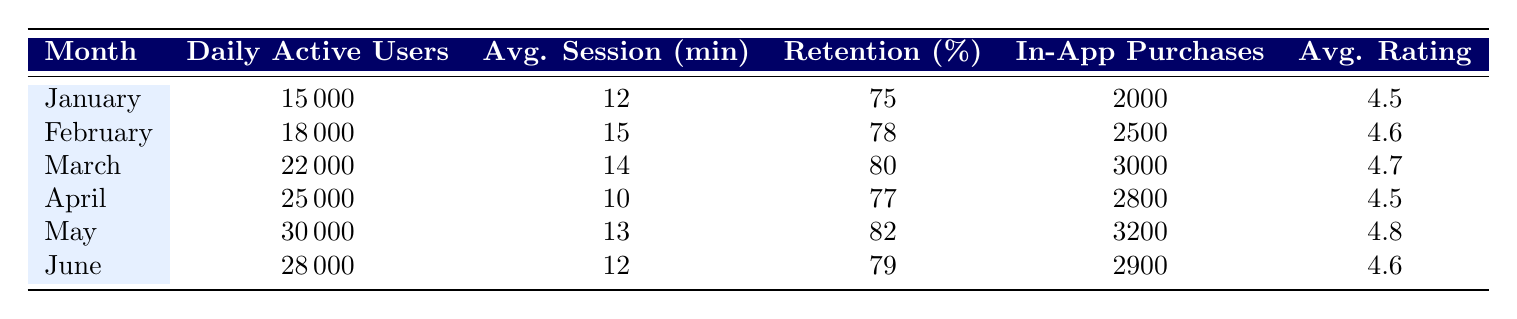What were the daily active users in March? In March, the row corresponding to that month shows 22000 daily active users.
Answer: 22000 What was the average session length in May? The average session length for May is directly provided in the table as 13 minutes.
Answer: 13 Did the user retention rate increase from February to March? In February, the user retention rate was 78%, while in March it was 80%. Since 80% is greater than 78%, the retention rate did increase from February to March.
Answer: Yes Which month had the highest number of in-app purchases? To find the highest in-app purchases, we compare the values: January (2000), February (2500), March (3000), April (2800), May (3200), and June (2900). The highest value is 3200 in May.
Answer: May What is the average rating across all six months? To calculate the average rating, sum the ratings (4.5 + 4.6 + 4.7 + 4.5 + 4.8 + 4.6 = 27.7) and divide by the number of months (6). Thus, 27.7 / 6 = 4.61667, which rounds to approximately 4.6.
Answer: 4.6 Was the average session length in April lower than in June? In April, the average session length was 10 minutes and in June it was 12 minutes. Since 10 is less than 12, April had a lower average session length compared to June.
Answer: Yes How many in-app purchases were made in the months of May and June combined? The in-app purchases in May are 3200 and in June are 2900. Adding these gives 3200 + 2900 = 6100 in-app purchases combined.
Answer: 6100 Which month had the lowest user retention rate? Reviewing the retention rates for each month shows the following: January (75), February (78), March (80), April (77), May (82), June (79). The lowest value is 75 in January.
Answer: January How many daily active users were added from January to February? To find the increase in daily active users from January (15000) to February (18000), subtract January's users from February's: 18000 - 15000 = 3000.
Answer: 3000 